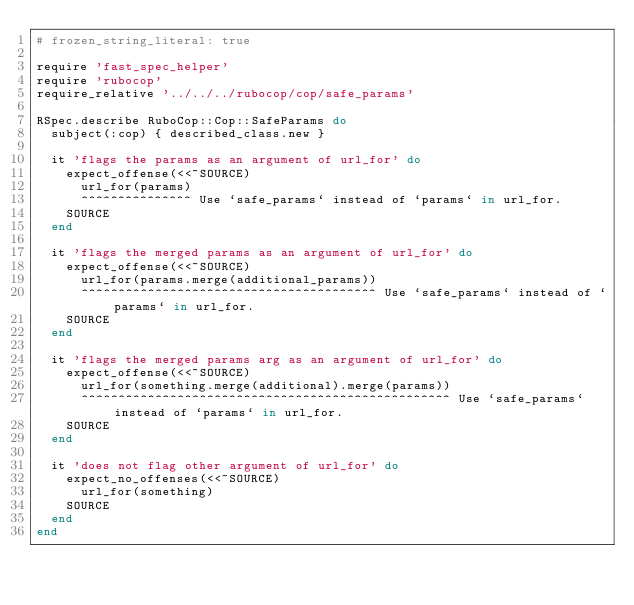<code> <loc_0><loc_0><loc_500><loc_500><_Ruby_># frozen_string_literal: true

require 'fast_spec_helper'
require 'rubocop'
require_relative '../../../rubocop/cop/safe_params'

RSpec.describe RuboCop::Cop::SafeParams do
  subject(:cop) { described_class.new }

  it 'flags the params as an argument of url_for' do
    expect_offense(<<~SOURCE)
      url_for(params)
      ^^^^^^^^^^^^^^^ Use `safe_params` instead of `params` in url_for.
    SOURCE
  end

  it 'flags the merged params as an argument of url_for' do
    expect_offense(<<~SOURCE)
      url_for(params.merge(additional_params))
      ^^^^^^^^^^^^^^^^^^^^^^^^^^^^^^^^^^^^^^^^ Use `safe_params` instead of `params` in url_for.
    SOURCE
  end

  it 'flags the merged params arg as an argument of url_for' do
    expect_offense(<<~SOURCE)
      url_for(something.merge(additional).merge(params))
      ^^^^^^^^^^^^^^^^^^^^^^^^^^^^^^^^^^^^^^^^^^^^^^^^^^ Use `safe_params` instead of `params` in url_for.
    SOURCE
  end

  it 'does not flag other argument of url_for' do
    expect_no_offenses(<<~SOURCE)
      url_for(something)
    SOURCE
  end
end
</code> 